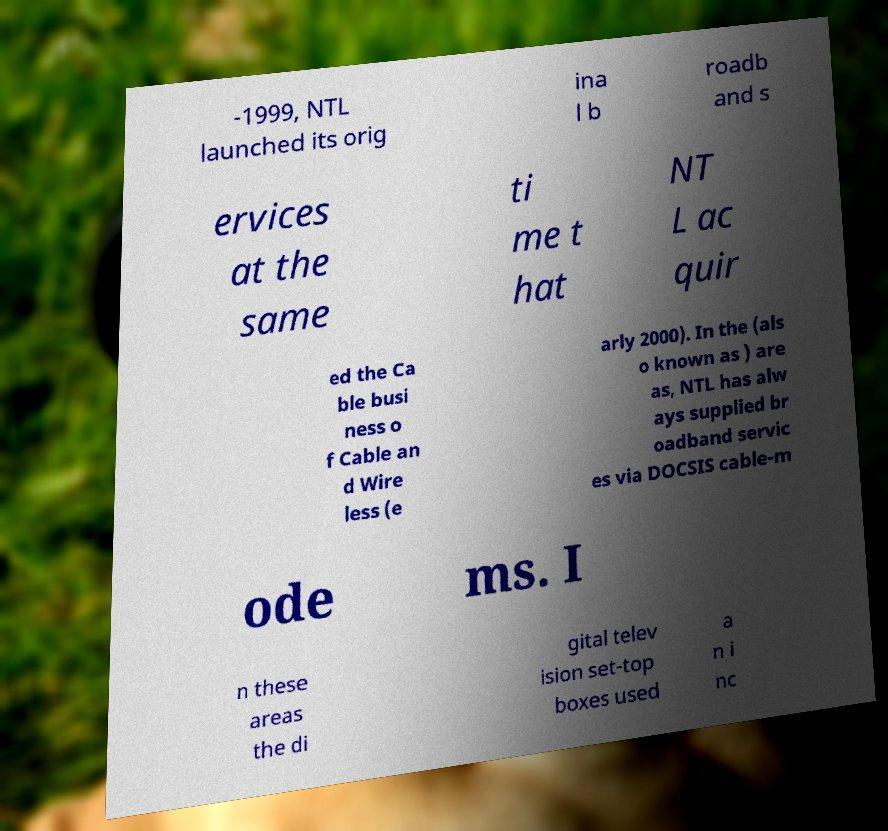Could you assist in decoding the text presented in this image and type it out clearly? -1999, NTL launched its orig ina l b roadb and s ervices at the same ti me t hat NT L ac quir ed the Ca ble busi ness o f Cable an d Wire less (e arly 2000). In the (als o known as ) are as, NTL has alw ays supplied br oadband servic es via DOCSIS cable-m ode ms. I n these areas the di gital telev ision set-top boxes used a n i nc 